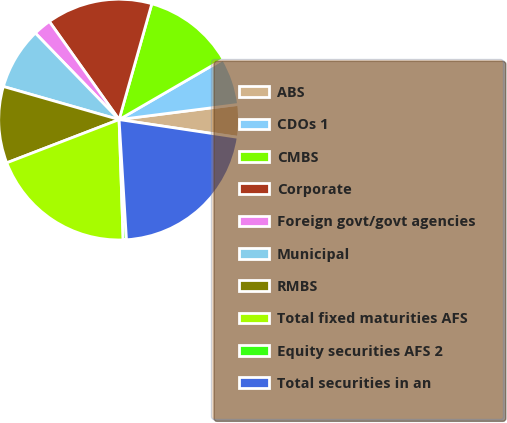<chart> <loc_0><loc_0><loc_500><loc_500><pie_chart><fcel>ABS<fcel>CDOs 1<fcel>CMBS<fcel>Corporate<fcel>Foreign govt/govt agencies<fcel>Municipal<fcel>RMBS<fcel>Total fixed maturities AFS<fcel>Equity securities AFS 2<fcel>Total securities in an<nl><fcel>4.38%<fcel>6.35%<fcel>12.25%<fcel>14.22%<fcel>2.41%<fcel>8.32%<fcel>10.28%<fcel>19.69%<fcel>0.44%<fcel>21.66%<nl></chart> 